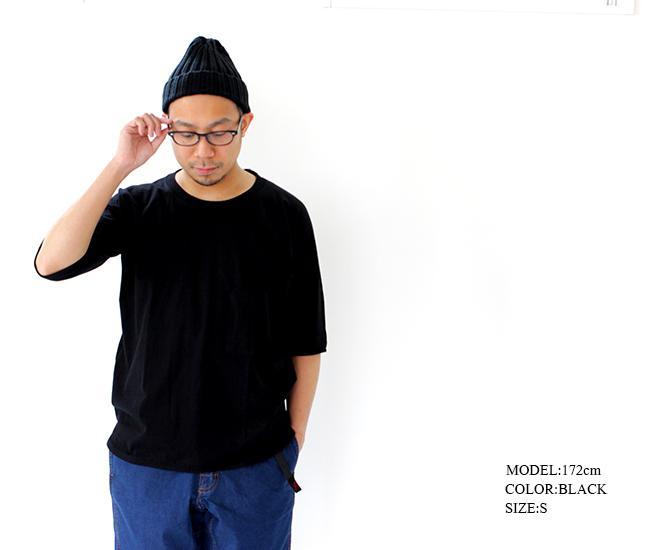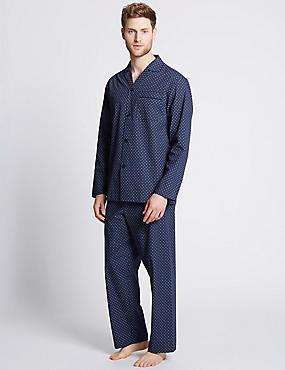The first image is the image on the left, the second image is the image on the right. For the images shown, is this caption "The man in the left image is wearing a hat." true? Answer yes or no. Yes. The first image is the image on the left, the second image is the image on the right. Considering the images on both sides, is "One man is wearing something on his head." valid? Answer yes or no. Yes. 